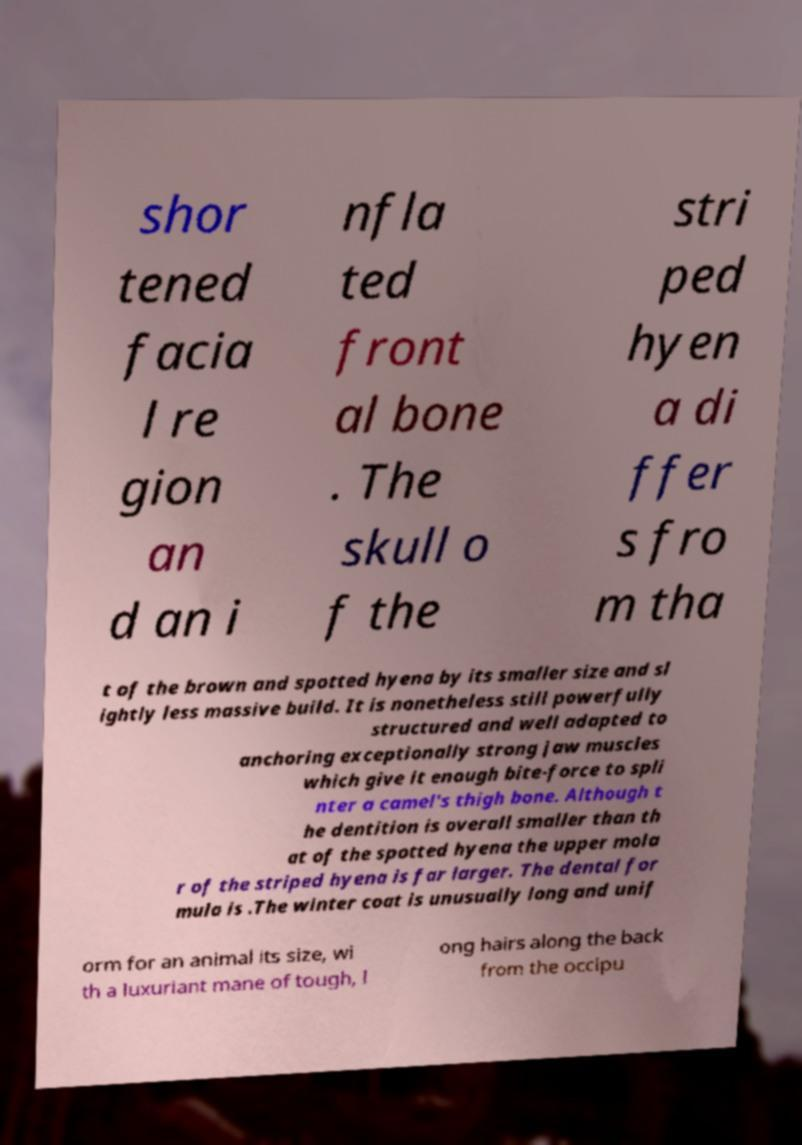Could you extract and type out the text from this image? shor tened facia l re gion an d an i nfla ted front al bone . The skull o f the stri ped hyen a di ffer s fro m tha t of the brown and spotted hyena by its smaller size and sl ightly less massive build. It is nonetheless still powerfully structured and well adapted to anchoring exceptionally strong jaw muscles which give it enough bite-force to spli nter a camel's thigh bone. Although t he dentition is overall smaller than th at of the spotted hyena the upper mola r of the striped hyena is far larger. The dental for mula is .The winter coat is unusually long and unif orm for an animal its size, wi th a luxuriant mane of tough, l ong hairs along the back from the occipu 